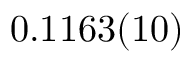Convert formula to latex. <formula><loc_0><loc_0><loc_500><loc_500>0 . 1 1 6 3 ( 1 0 )</formula> 